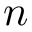<formula> <loc_0><loc_0><loc_500><loc_500>n</formula> 